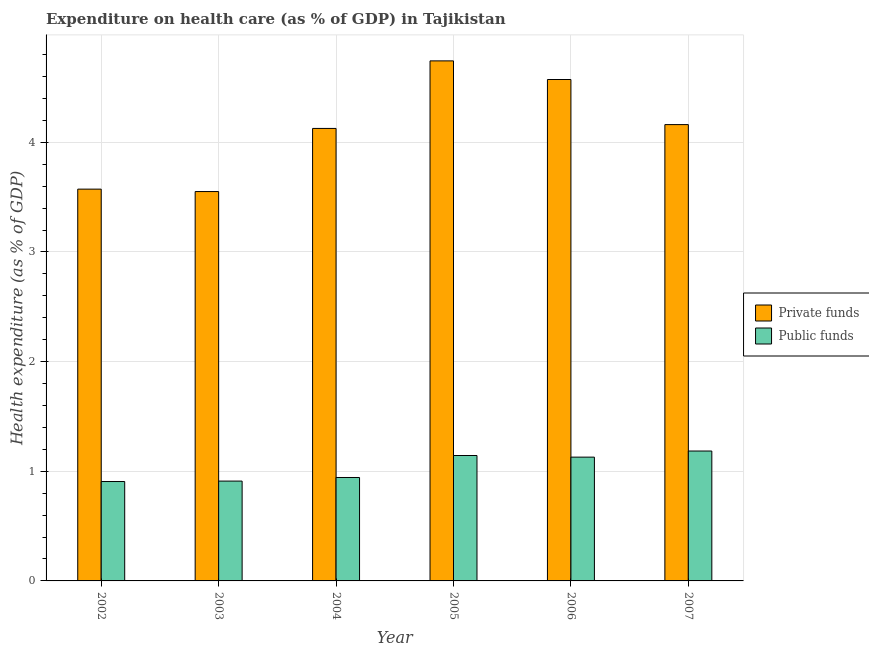How many different coloured bars are there?
Your answer should be very brief. 2. Are the number of bars on each tick of the X-axis equal?
Your answer should be compact. Yes. How many bars are there on the 3rd tick from the left?
Provide a succinct answer. 2. In how many cases, is the number of bars for a given year not equal to the number of legend labels?
Give a very brief answer. 0. What is the amount of private funds spent in healthcare in 2007?
Provide a short and direct response. 4.16. Across all years, what is the maximum amount of public funds spent in healthcare?
Offer a terse response. 1.18. Across all years, what is the minimum amount of private funds spent in healthcare?
Your answer should be compact. 3.55. In which year was the amount of public funds spent in healthcare minimum?
Give a very brief answer. 2002. What is the total amount of public funds spent in healthcare in the graph?
Your response must be concise. 6.22. What is the difference between the amount of private funds spent in healthcare in 2004 and that in 2005?
Offer a very short reply. -0.62. What is the difference between the amount of private funds spent in healthcare in 2005 and the amount of public funds spent in healthcare in 2007?
Give a very brief answer. 0.58. What is the average amount of private funds spent in healthcare per year?
Keep it short and to the point. 4.12. In the year 2005, what is the difference between the amount of public funds spent in healthcare and amount of private funds spent in healthcare?
Make the answer very short. 0. In how many years, is the amount of private funds spent in healthcare greater than 1.6 %?
Give a very brief answer. 6. What is the ratio of the amount of private funds spent in healthcare in 2004 to that in 2007?
Keep it short and to the point. 0.99. Is the amount of private funds spent in healthcare in 2003 less than that in 2007?
Provide a succinct answer. Yes. What is the difference between the highest and the second highest amount of public funds spent in healthcare?
Your answer should be compact. 0.04. What is the difference between the highest and the lowest amount of public funds spent in healthcare?
Your response must be concise. 0.28. In how many years, is the amount of private funds spent in healthcare greater than the average amount of private funds spent in healthcare taken over all years?
Give a very brief answer. 4. Is the sum of the amount of public funds spent in healthcare in 2005 and 2006 greater than the maximum amount of private funds spent in healthcare across all years?
Keep it short and to the point. Yes. What does the 1st bar from the left in 2003 represents?
Your response must be concise. Private funds. What does the 2nd bar from the right in 2005 represents?
Give a very brief answer. Private funds. Are all the bars in the graph horizontal?
Offer a very short reply. No. What is the difference between two consecutive major ticks on the Y-axis?
Keep it short and to the point. 1. Are the values on the major ticks of Y-axis written in scientific E-notation?
Your answer should be compact. No. What is the title of the graph?
Provide a short and direct response. Expenditure on health care (as % of GDP) in Tajikistan. Does "Girls" appear as one of the legend labels in the graph?
Offer a very short reply. No. What is the label or title of the Y-axis?
Give a very brief answer. Health expenditure (as % of GDP). What is the Health expenditure (as % of GDP) of Private funds in 2002?
Provide a succinct answer. 3.57. What is the Health expenditure (as % of GDP) in Public funds in 2002?
Your answer should be compact. 0.91. What is the Health expenditure (as % of GDP) in Private funds in 2003?
Make the answer very short. 3.55. What is the Health expenditure (as % of GDP) in Public funds in 2003?
Make the answer very short. 0.91. What is the Health expenditure (as % of GDP) in Private funds in 2004?
Your answer should be very brief. 4.13. What is the Health expenditure (as % of GDP) of Public funds in 2004?
Ensure brevity in your answer.  0.94. What is the Health expenditure (as % of GDP) in Private funds in 2005?
Provide a succinct answer. 4.74. What is the Health expenditure (as % of GDP) in Public funds in 2005?
Make the answer very short. 1.14. What is the Health expenditure (as % of GDP) in Private funds in 2006?
Offer a terse response. 4.57. What is the Health expenditure (as % of GDP) in Public funds in 2006?
Keep it short and to the point. 1.13. What is the Health expenditure (as % of GDP) in Private funds in 2007?
Offer a very short reply. 4.16. What is the Health expenditure (as % of GDP) of Public funds in 2007?
Ensure brevity in your answer.  1.18. Across all years, what is the maximum Health expenditure (as % of GDP) in Private funds?
Give a very brief answer. 4.74. Across all years, what is the maximum Health expenditure (as % of GDP) of Public funds?
Offer a very short reply. 1.18. Across all years, what is the minimum Health expenditure (as % of GDP) of Private funds?
Your response must be concise. 3.55. Across all years, what is the minimum Health expenditure (as % of GDP) in Public funds?
Make the answer very short. 0.91. What is the total Health expenditure (as % of GDP) of Private funds in the graph?
Provide a short and direct response. 24.73. What is the total Health expenditure (as % of GDP) in Public funds in the graph?
Offer a very short reply. 6.22. What is the difference between the Health expenditure (as % of GDP) of Private funds in 2002 and that in 2003?
Provide a short and direct response. 0.02. What is the difference between the Health expenditure (as % of GDP) in Public funds in 2002 and that in 2003?
Offer a very short reply. -0. What is the difference between the Health expenditure (as % of GDP) of Private funds in 2002 and that in 2004?
Provide a short and direct response. -0.55. What is the difference between the Health expenditure (as % of GDP) of Public funds in 2002 and that in 2004?
Your answer should be very brief. -0.04. What is the difference between the Health expenditure (as % of GDP) in Private funds in 2002 and that in 2005?
Offer a terse response. -1.17. What is the difference between the Health expenditure (as % of GDP) of Public funds in 2002 and that in 2005?
Give a very brief answer. -0.24. What is the difference between the Health expenditure (as % of GDP) of Private funds in 2002 and that in 2006?
Ensure brevity in your answer.  -1. What is the difference between the Health expenditure (as % of GDP) in Public funds in 2002 and that in 2006?
Provide a succinct answer. -0.22. What is the difference between the Health expenditure (as % of GDP) in Private funds in 2002 and that in 2007?
Ensure brevity in your answer.  -0.59. What is the difference between the Health expenditure (as % of GDP) in Public funds in 2002 and that in 2007?
Provide a short and direct response. -0.28. What is the difference between the Health expenditure (as % of GDP) in Private funds in 2003 and that in 2004?
Your answer should be compact. -0.58. What is the difference between the Health expenditure (as % of GDP) in Public funds in 2003 and that in 2004?
Your answer should be compact. -0.03. What is the difference between the Health expenditure (as % of GDP) of Private funds in 2003 and that in 2005?
Your response must be concise. -1.19. What is the difference between the Health expenditure (as % of GDP) in Public funds in 2003 and that in 2005?
Provide a succinct answer. -0.23. What is the difference between the Health expenditure (as % of GDP) of Private funds in 2003 and that in 2006?
Offer a terse response. -1.02. What is the difference between the Health expenditure (as % of GDP) of Public funds in 2003 and that in 2006?
Offer a very short reply. -0.22. What is the difference between the Health expenditure (as % of GDP) of Private funds in 2003 and that in 2007?
Provide a succinct answer. -0.61. What is the difference between the Health expenditure (as % of GDP) of Public funds in 2003 and that in 2007?
Your answer should be very brief. -0.27. What is the difference between the Health expenditure (as % of GDP) of Private funds in 2004 and that in 2005?
Offer a very short reply. -0.62. What is the difference between the Health expenditure (as % of GDP) of Public funds in 2004 and that in 2005?
Make the answer very short. -0.2. What is the difference between the Health expenditure (as % of GDP) in Private funds in 2004 and that in 2006?
Your response must be concise. -0.45. What is the difference between the Health expenditure (as % of GDP) in Public funds in 2004 and that in 2006?
Ensure brevity in your answer.  -0.19. What is the difference between the Health expenditure (as % of GDP) in Private funds in 2004 and that in 2007?
Ensure brevity in your answer.  -0.04. What is the difference between the Health expenditure (as % of GDP) in Public funds in 2004 and that in 2007?
Offer a terse response. -0.24. What is the difference between the Health expenditure (as % of GDP) of Private funds in 2005 and that in 2006?
Provide a short and direct response. 0.17. What is the difference between the Health expenditure (as % of GDP) of Public funds in 2005 and that in 2006?
Your response must be concise. 0.01. What is the difference between the Health expenditure (as % of GDP) in Private funds in 2005 and that in 2007?
Provide a succinct answer. 0.58. What is the difference between the Health expenditure (as % of GDP) in Public funds in 2005 and that in 2007?
Your answer should be compact. -0.04. What is the difference between the Health expenditure (as % of GDP) in Private funds in 2006 and that in 2007?
Provide a succinct answer. 0.41. What is the difference between the Health expenditure (as % of GDP) of Public funds in 2006 and that in 2007?
Offer a very short reply. -0.06. What is the difference between the Health expenditure (as % of GDP) of Private funds in 2002 and the Health expenditure (as % of GDP) of Public funds in 2003?
Give a very brief answer. 2.66. What is the difference between the Health expenditure (as % of GDP) of Private funds in 2002 and the Health expenditure (as % of GDP) of Public funds in 2004?
Offer a terse response. 2.63. What is the difference between the Health expenditure (as % of GDP) of Private funds in 2002 and the Health expenditure (as % of GDP) of Public funds in 2005?
Your answer should be compact. 2.43. What is the difference between the Health expenditure (as % of GDP) in Private funds in 2002 and the Health expenditure (as % of GDP) in Public funds in 2006?
Ensure brevity in your answer.  2.44. What is the difference between the Health expenditure (as % of GDP) in Private funds in 2002 and the Health expenditure (as % of GDP) in Public funds in 2007?
Offer a very short reply. 2.39. What is the difference between the Health expenditure (as % of GDP) of Private funds in 2003 and the Health expenditure (as % of GDP) of Public funds in 2004?
Your answer should be compact. 2.61. What is the difference between the Health expenditure (as % of GDP) in Private funds in 2003 and the Health expenditure (as % of GDP) in Public funds in 2005?
Your answer should be compact. 2.41. What is the difference between the Health expenditure (as % of GDP) of Private funds in 2003 and the Health expenditure (as % of GDP) of Public funds in 2006?
Your answer should be very brief. 2.42. What is the difference between the Health expenditure (as % of GDP) of Private funds in 2003 and the Health expenditure (as % of GDP) of Public funds in 2007?
Offer a very short reply. 2.37. What is the difference between the Health expenditure (as % of GDP) in Private funds in 2004 and the Health expenditure (as % of GDP) in Public funds in 2005?
Provide a succinct answer. 2.98. What is the difference between the Health expenditure (as % of GDP) of Private funds in 2004 and the Health expenditure (as % of GDP) of Public funds in 2006?
Provide a short and direct response. 3. What is the difference between the Health expenditure (as % of GDP) of Private funds in 2004 and the Health expenditure (as % of GDP) of Public funds in 2007?
Give a very brief answer. 2.94. What is the difference between the Health expenditure (as % of GDP) in Private funds in 2005 and the Health expenditure (as % of GDP) in Public funds in 2006?
Offer a terse response. 3.61. What is the difference between the Health expenditure (as % of GDP) of Private funds in 2005 and the Health expenditure (as % of GDP) of Public funds in 2007?
Your answer should be compact. 3.56. What is the difference between the Health expenditure (as % of GDP) of Private funds in 2006 and the Health expenditure (as % of GDP) of Public funds in 2007?
Make the answer very short. 3.39. What is the average Health expenditure (as % of GDP) of Private funds per year?
Your answer should be very brief. 4.12. What is the average Health expenditure (as % of GDP) in Public funds per year?
Offer a very short reply. 1.04. In the year 2002, what is the difference between the Health expenditure (as % of GDP) of Private funds and Health expenditure (as % of GDP) of Public funds?
Give a very brief answer. 2.67. In the year 2003, what is the difference between the Health expenditure (as % of GDP) of Private funds and Health expenditure (as % of GDP) of Public funds?
Provide a succinct answer. 2.64. In the year 2004, what is the difference between the Health expenditure (as % of GDP) of Private funds and Health expenditure (as % of GDP) of Public funds?
Offer a terse response. 3.18. In the year 2005, what is the difference between the Health expenditure (as % of GDP) of Private funds and Health expenditure (as % of GDP) of Public funds?
Provide a succinct answer. 3.6. In the year 2006, what is the difference between the Health expenditure (as % of GDP) of Private funds and Health expenditure (as % of GDP) of Public funds?
Give a very brief answer. 3.44. In the year 2007, what is the difference between the Health expenditure (as % of GDP) of Private funds and Health expenditure (as % of GDP) of Public funds?
Ensure brevity in your answer.  2.98. What is the ratio of the Health expenditure (as % of GDP) of Private funds in 2002 to that in 2004?
Make the answer very short. 0.87. What is the ratio of the Health expenditure (as % of GDP) in Private funds in 2002 to that in 2005?
Your response must be concise. 0.75. What is the ratio of the Health expenditure (as % of GDP) in Public funds in 2002 to that in 2005?
Provide a succinct answer. 0.79. What is the ratio of the Health expenditure (as % of GDP) in Private funds in 2002 to that in 2006?
Make the answer very short. 0.78. What is the ratio of the Health expenditure (as % of GDP) of Public funds in 2002 to that in 2006?
Your response must be concise. 0.8. What is the ratio of the Health expenditure (as % of GDP) in Private funds in 2002 to that in 2007?
Make the answer very short. 0.86. What is the ratio of the Health expenditure (as % of GDP) in Public funds in 2002 to that in 2007?
Ensure brevity in your answer.  0.77. What is the ratio of the Health expenditure (as % of GDP) of Private funds in 2003 to that in 2004?
Offer a very short reply. 0.86. What is the ratio of the Health expenditure (as % of GDP) in Public funds in 2003 to that in 2004?
Keep it short and to the point. 0.97. What is the ratio of the Health expenditure (as % of GDP) in Private funds in 2003 to that in 2005?
Provide a succinct answer. 0.75. What is the ratio of the Health expenditure (as % of GDP) in Public funds in 2003 to that in 2005?
Your response must be concise. 0.8. What is the ratio of the Health expenditure (as % of GDP) of Private funds in 2003 to that in 2006?
Offer a terse response. 0.78. What is the ratio of the Health expenditure (as % of GDP) in Public funds in 2003 to that in 2006?
Keep it short and to the point. 0.81. What is the ratio of the Health expenditure (as % of GDP) in Private funds in 2003 to that in 2007?
Give a very brief answer. 0.85. What is the ratio of the Health expenditure (as % of GDP) of Public funds in 2003 to that in 2007?
Your response must be concise. 0.77. What is the ratio of the Health expenditure (as % of GDP) in Private funds in 2004 to that in 2005?
Provide a succinct answer. 0.87. What is the ratio of the Health expenditure (as % of GDP) in Public funds in 2004 to that in 2005?
Provide a short and direct response. 0.82. What is the ratio of the Health expenditure (as % of GDP) in Private funds in 2004 to that in 2006?
Your answer should be compact. 0.9. What is the ratio of the Health expenditure (as % of GDP) of Public funds in 2004 to that in 2006?
Offer a terse response. 0.84. What is the ratio of the Health expenditure (as % of GDP) of Private funds in 2004 to that in 2007?
Offer a very short reply. 0.99. What is the ratio of the Health expenditure (as % of GDP) of Public funds in 2004 to that in 2007?
Your response must be concise. 0.8. What is the ratio of the Health expenditure (as % of GDP) of Private funds in 2005 to that in 2006?
Provide a succinct answer. 1.04. What is the ratio of the Health expenditure (as % of GDP) of Public funds in 2005 to that in 2006?
Your answer should be compact. 1.01. What is the ratio of the Health expenditure (as % of GDP) of Private funds in 2005 to that in 2007?
Ensure brevity in your answer.  1.14. What is the ratio of the Health expenditure (as % of GDP) of Public funds in 2005 to that in 2007?
Provide a short and direct response. 0.97. What is the ratio of the Health expenditure (as % of GDP) in Private funds in 2006 to that in 2007?
Provide a short and direct response. 1.1. What is the ratio of the Health expenditure (as % of GDP) of Public funds in 2006 to that in 2007?
Ensure brevity in your answer.  0.95. What is the difference between the highest and the second highest Health expenditure (as % of GDP) of Private funds?
Make the answer very short. 0.17. What is the difference between the highest and the second highest Health expenditure (as % of GDP) in Public funds?
Give a very brief answer. 0.04. What is the difference between the highest and the lowest Health expenditure (as % of GDP) of Private funds?
Your response must be concise. 1.19. What is the difference between the highest and the lowest Health expenditure (as % of GDP) in Public funds?
Give a very brief answer. 0.28. 